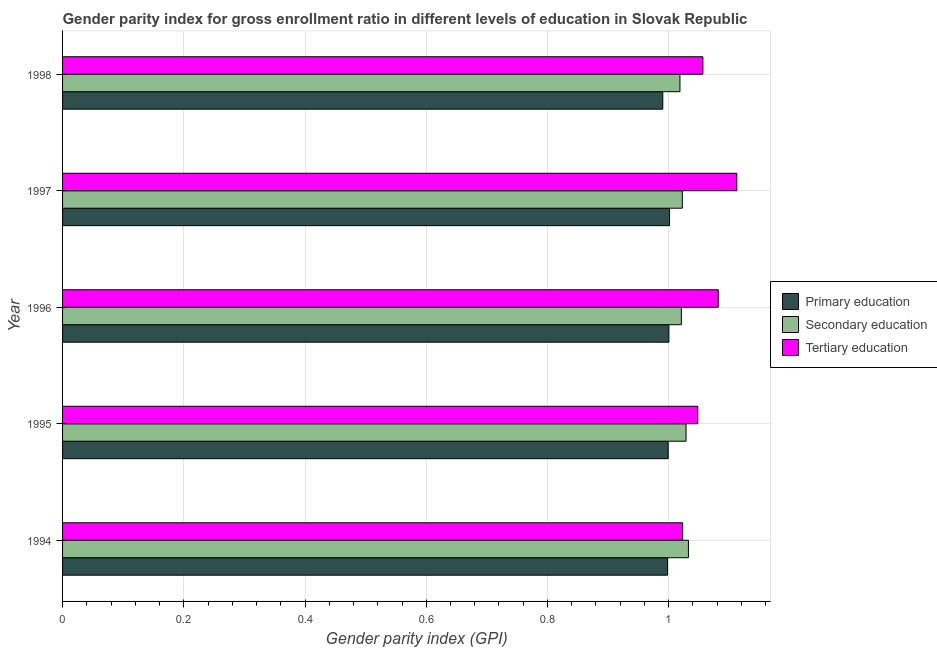How many groups of bars are there?
Offer a terse response. 5. Are the number of bars on each tick of the Y-axis equal?
Offer a terse response. Yes. How many bars are there on the 2nd tick from the top?
Provide a succinct answer. 3. How many bars are there on the 2nd tick from the bottom?
Give a very brief answer. 3. What is the label of the 3rd group of bars from the top?
Offer a terse response. 1996. In how many cases, is the number of bars for a given year not equal to the number of legend labels?
Your answer should be compact. 0. What is the gender parity index in primary education in 1997?
Give a very brief answer. 1. Across all years, what is the maximum gender parity index in tertiary education?
Provide a short and direct response. 1.11. Across all years, what is the minimum gender parity index in secondary education?
Offer a terse response. 1.02. What is the total gender parity index in tertiary education in the graph?
Give a very brief answer. 5.32. What is the difference between the gender parity index in secondary education in 1994 and that in 1998?
Offer a very short reply. 0.01. What is the difference between the gender parity index in primary education in 1998 and the gender parity index in tertiary education in 1997?
Provide a short and direct response. -0.12. What is the average gender parity index in tertiary education per year?
Your answer should be very brief. 1.06. In the year 1997, what is the difference between the gender parity index in secondary education and gender parity index in primary education?
Keep it short and to the point. 0.02. What is the ratio of the gender parity index in tertiary education in 1994 to that in 1998?
Your answer should be very brief. 0.97. Is the gender parity index in primary education in 1995 less than that in 1997?
Provide a short and direct response. Yes. What is the difference between the highest and the second highest gender parity index in tertiary education?
Your response must be concise. 0.03. What is the difference between the highest and the lowest gender parity index in secondary education?
Your answer should be compact. 0.01. In how many years, is the gender parity index in primary education greater than the average gender parity index in primary education taken over all years?
Provide a short and direct response. 4. Is the sum of the gender parity index in tertiary education in 1996 and 1997 greater than the maximum gender parity index in secondary education across all years?
Your answer should be very brief. Yes. What does the 2nd bar from the top in 1998 represents?
Provide a short and direct response. Secondary education. What does the 2nd bar from the bottom in 1996 represents?
Provide a succinct answer. Secondary education. Are all the bars in the graph horizontal?
Provide a short and direct response. Yes. How many years are there in the graph?
Give a very brief answer. 5. Are the values on the major ticks of X-axis written in scientific E-notation?
Provide a succinct answer. No. Does the graph contain any zero values?
Provide a succinct answer. No. What is the title of the graph?
Provide a short and direct response. Gender parity index for gross enrollment ratio in different levels of education in Slovak Republic. Does "Natural Gas" appear as one of the legend labels in the graph?
Provide a succinct answer. No. What is the label or title of the X-axis?
Your answer should be very brief. Gender parity index (GPI). What is the label or title of the Y-axis?
Provide a succinct answer. Year. What is the Gender parity index (GPI) in Primary education in 1994?
Provide a short and direct response. 1. What is the Gender parity index (GPI) in Secondary education in 1994?
Offer a very short reply. 1.03. What is the Gender parity index (GPI) in Tertiary education in 1994?
Ensure brevity in your answer.  1.02. What is the Gender parity index (GPI) of Primary education in 1995?
Your answer should be compact. 1. What is the Gender parity index (GPI) in Secondary education in 1995?
Offer a terse response. 1.03. What is the Gender parity index (GPI) of Tertiary education in 1995?
Your answer should be very brief. 1.05. What is the Gender parity index (GPI) in Primary education in 1996?
Your answer should be very brief. 1. What is the Gender parity index (GPI) in Secondary education in 1996?
Provide a short and direct response. 1.02. What is the Gender parity index (GPI) of Tertiary education in 1996?
Keep it short and to the point. 1.08. What is the Gender parity index (GPI) of Primary education in 1997?
Your response must be concise. 1. What is the Gender parity index (GPI) in Secondary education in 1997?
Your answer should be compact. 1.02. What is the Gender parity index (GPI) of Tertiary education in 1997?
Offer a very short reply. 1.11. What is the Gender parity index (GPI) in Primary education in 1998?
Make the answer very short. 0.99. What is the Gender parity index (GPI) in Secondary education in 1998?
Give a very brief answer. 1.02. What is the Gender parity index (GPI) in Tertiary education in 1998?
Keep it short and to the point. 1.06. Across all years, what is the maximum Gender parity index (GPI) in Primary education?
Ensure brevity in your answer.  1. Across all years, what is the maximum Gender parity index (GPI) of Secondary education?
Make the answer very short. 1.03. Across all years, what is the maximum Gender parity index (GPI) of Tertiary education?
Keep it short and to the point. 1.11. Across all years, what is the minimum Gender parity index (GPI) in Primary education?
Your answer should be very brief. 0.99. Across all years, what is the minimum Gender parity index (GPI) in Secondary education?
Your answer should be very brief. 1.02. Across all years, what is the minimum Gender parity index (GPI) of Tertiary education?
Your answer should be compact. 1.02. What is the total Gender parity index (GPI) in Primary education in the graph?
Provide a succinct answer. 4.99. What is the total Gender parity index (GPI) of Secondary education in the graph?
Your response must be concise. 5.12. What is the total Gender parity index (GPI) in Tertiary education in the graph?
Give a very brief answer. 5.32. What is the difference between the Gender parity index (GPI) in Primary education in 1994 and that in 1995?
Provide a short and direct response. -0. What is the difference between the Gender parity index (GPI) of Secondary education in 1994 and that in 1995?
Ensure brevity in your answer.  0. What is the difference between the Gender parity index (GPI) of Tertiary education in 1994 and that in 1995?
Give a very brief answer. -0.03. What is the difference between the Gender parity index (GPI) of Primary education in 1994 and that in 1996?
Your response must be concise. -0. What is the difference between the Gender parity index (GPI) in Secondary education in 1994 and that in 1996?
Keep it short and to the point. 0.01. What is the difference between the Gender parity index (GPI) of Tertiary education in 1994 and that in 1996?
Offer a terse response. -0.06. What is the difference between the Gender parity index (GPI) in Primary education in 1994 and that in 1997?
Keep it short and to the point. -0. What is the difference between the Gender parity index (GPI) in Secondary education in 1994 and that in 1997?
Your response must be concise. 0.01. What is the difference between the Gender parity index (GPI) in Tertiary education in 1994 and that in 1997?
Ensure brevity in your answer.  -0.09. What is the difference between the Gender parity index (GPI) of Primary education in 1994 and that in 1998?
Provide a short and direct response. 0.01. What is the difference between the Gender parity index (GPI) of Secondary education in 1994 and that in 1998?
Your answer should be very brief. 0.01. What is the difference between the Gender parity index (GPI) of Tertiary education in 1994 and that in 1998?
Make the answer very short. -0.03. What is the difference between the Gender parity index (GPI) of Primary education in 1995 and that in 1996?
Keep it short and to the point. -0. What is the difference between the Gender parity index (GPI) in Secondary education in 1995 and that in 1996?
Provide a succinct answer. 0.01. What is the difference between the Gender parity index (GPI) in Tertiary education in 1995 and that in 1996?
Offer a very short reply. -0.03. What is the difference between the Gender parity index (GPI) in Primary education in 1995 and that in 1997?
Your answer should be very brief. -0. What is the difference between the Gender parity index (GPI) of Secondary education in 1995 and that in 1997?
Offer a very short reply. 0.01. What is the difference between the Gender parity index (GPI) in Tertiary education in 1995 and that in 1997?
Ensure brevity in your answer.  -0.06. What is the difference between the Gender parity index (GPI) in Primary education in 1995 and that in 1998?
Your answer should be compact. 0.01. What is the difference between the Gender parity index (GPI) of Secondary education in 1995 and that in 1998?
Ensure brevity in your answer.  0.01. What is the difference between the Gender parity index (GPI) of Tertiary education in 1995 and that in 1998?
Provide a succinct answer. -0.01. What is the difference between the Gender parity index (GPI) of Primary education in 1996 and that in 1997?
Make the answer very short. -0. What is the difference between the Gender parity index (GPI) of Secondary education in 1996 and that in 1997?
Offer a terse response. -0. What is the difference between the Gender parity index (GPI) of Tertiary education in 1996 and that in 1997?
Offer a very short reply. -0.03. What is the difference between the Gender parity index (GPI) in Primary education in 1996 and that in 1998?
Keep it short and to the point. 0.01. What is the difference between the Gender parity index (GPI) in Secondary education in 1996 and that in 1998?
Make the answer very short. 0. What is the difference between the Gender parity index (GPI) of Tertiary education in 1996 and that in 1998?
Offer a terse response. 0.03. What is the difference between the Gender parity index (GPI) of Primary education in 1997 and that in 1998?
Keep it short and to the point. 0.01. What is the difference between the Gender parity index (GPI) in Secondary education in 1997 and that in 1998?
Provide a short and direct response. 0. What is the difference between the Gender parity index (GPI) in Tertiary education in 1997 and that in 1998?
Make the answer very short. 0.06. What is the difference between the Gender parity index (GPI) in Primary education in 1994 and the Gender parity index (GPI) in Secondary education in 1995?
Offer a very short reply. -0.03. What is the difference between the Gender parity index (GPI) in Primary education in 1994 and the Gender parity index (GPI) in Tertiary education in 1995?
Your answer should be very brief. -0.05. What is the difference between the Gender parity index (GPI) in Secondary education in 1994 and the Gender parity index (GPI) in Tertiary education in 1995?
Give a very brief answer. -0.02. What is the difference between the Gender parity index (GPI) in Primary education in 1994 and the Gender parity index (GPI) in Secondary education in 1996?
Provide a succinct answer. -0.02. What is the difference between the Gender parity index (GPI) of Primary education in 1994 and the Gender parity index (GPI) of Tertiary education in 1996?
Make the answer very short. -0.08. What is the difference between the Gender parity index (GPI) in Secondary education in 1994 and the Gender parity index (GPI) in Tertiary education in 1996?
Keep it short and to the point. -0.05. What is the difference between the Gender parity index (GPI) in Primary education in 1994 and the Gender parity index (GPI) in Secondary education in 1997?
Provide a short and direct response. -0.02. What is the difference between the Gender parity index (GPI) of Primary education in 1994 and the Gender parity index (GPI) of Tertiary education in 1997?
Provide a succinct answer. -0.11. What is the difference between the Gender parity index (GPI) in Secondary education in 1994 and the Gender parity index (GPI) in Tertiary education in 1997?
Make the answer very short. -0.08. What is the difference between the Gender parity index (GPI) of Primary education in 1994 and the Gender parity index (GPI) of Secondary education in 1998?
Your answer should be compact. -0.02. What is the difference between the Gender parity index (GPI) of Primary education in 1994 and the Gender parity index (GPI) of Tertiary education in 1998?
Your response must be concise. -0.06. What is the difference between the Gender parity index (GPI) of Secondary education in 1994 and the Gender parity index (GPI) of Tertiary education in 1998?
Offer a terse response. -0.02. What is the difference between the Gender parity index (GPI) in Primary education in 1995 and the Gender parity index (GPI) in Secondary education in 1996?
Offer a very short reply. -0.02. What is the difference between the Gender parity index (GPI) of Primary education in 1995 and the Gender parity index (GPI) of Tertiary education in 1996?
Your answer should be compact. -0.08. What is the difference between the Gender parity index (GPI) of Secondary education in 1995 and the Gender parity index (GPI) of Tertiary education in 1996?
Your response must be concise. -0.05. What is the difference between the Gender parity index (GPI) in Primary education in 1995 and the Gender parity index (GPI) in Secondary education in 1997?
Offer a terse response. -0.02. What is the difference between the Gender parity index (GPI) of Primary education in 1995 and the Gender parity index (GPI) of Tertiary education in 1997?
Offer a very short reply. -0.11. What is the difference between the Gender parity index (GPI) in Secondary education in 1995 and the Gender parity index (GPI) in Tertiary education in 1997?
Provide a succinct answer. -0.08. What is the difference between the Gender parity index (GPI) of Primary education in 1995 and the Gender parity index (GPI) of Secondary education in 1998?
Ensure brevity in your answer.  -0.02. What is the difference between the Gender parity index (GPI) of Primary education in 1995 and the Gender parity index (GPI) of Tertiary education in 1998?
Ensure brevity in your answer.  -0.06. What is the difference between the Gender parity index (GPI) in Secondary education in 1995 and the Gender parity index (GPI) in Tertiary education in 1998?
Offer a terse response. -0.03. What is the difference between the Gender parity index (GPI) of Primary education in 1996 and the Gender parity index (GPI) of Secondary education in 1997?
Provide a succinct answer. -0.02. What is the difference between the Gender parity index (GPI) of Primary education in 1996 and the Gender parity index (GPI) of Tertiary education in 1997?
Provide a succinct answer. -0.11. What is the difference between the Gender parity index (GPI) of Secondary education in 1996 and the Gender parity index (GPI) of Tertiary education in 1997?
Your response must be concise. -0.09. What is the difference between the Gender parity index (GPI) in Primary education in 1996 and the Gender parity index (GPI) in Secondary education in 1998?
Your response must be concise. -0.02. What is the difference between the Gender parity index (GPI) of Primary education in 1996 and the Gender parity index (GPI) of Tertiary education in 1998?
Your response must be concise. -0.06. What is the difference between the Gender parity index (GPI) of Secondary education in 1996 and the Gender parity index (GPI) of Tertiary education in 1998?
Ensure brevity in your answer.  -0.04. What is the difference between the Gender parity index (GPI) in Primary education in 1997 and the Gender parity index (GPI) in Secondary education in 1998?
Keep it short and to the point. -0.02. What is the difference between the Gender parity index (GPI) in Primary education in 1997 and the Gender parity index (GPI) in Tertiary education in 1998?
Provide a short and direct response. -0.06. What is the difference between the Gender parity index (GPI) in Secondary education in 1997 and the Gender parity index (GPI) in Tertiary education in 1998?
Make the answer very short. -0.03. What is the average Gender parity index (GPI) of Secondary education per year?
Your response must be concise. 1.02. What is the average Gender parity index (GPI) of Tertiary education per year?
Keep it short and to the point. 1.06. In the year 1994, what is the difference between the Gender parity index (GPI) in Primary education and Gender parity index (GPI) in Secondary education?
Give a very brief answer. -0.03. In the year 1994, what is the difference between the Gender parity index (GPI) in Primary education and Gender parity index (GPI) in Tertiary education?
Offer a terse response. -0.02. In the year 1994, what is the difference between the Gender parity index (GPI) in Secondary education and Gender parity index (GPI) in Tertiary education?
Make the answer very short. 0.01. In the year 1995, what is the difference between the Gender parity index (GPI) of Primary education and Gender parity index (GPI) of Secondary education?
Provide a succinct answer. -0.03. In the year 1995, what is the difference between the Gender parity index (GPI) of Primary education and Gender parity index (GPI) of Tertiary education?
Offer a terse response. -0.05. In the year 1995, what is the difference between the Gender parity index (GPI) of Secondary education and Gender parity index (GPI) of Tertiary education?
Your answer should be very brief. -0.02. In the year 1996, what is the difference between the Gender parity index (GPI) in Primary education and Gender parity index (GPI) in Secondary education?
Give a very brief answer. -0.02. In the year 1996, what is the difference between the Gender parity index (GPI) of Primary education and Gender parity index (GPI) of Tertiary education?
Provide a succinct answer. -0.08. In the year 1996, what is the difference between the Gender parity index (GPI) in Secondary education and Gender parity index (GPI) in Tertiary education?
Your answer should be compact. -0.06. In the year 1997, what is the difference between the Gender parity index (GPI) of Primary education and Gender parity index (GPI) of Secondary education?
Provide a short and direct response. -0.02. In the year 1997, what is the difference between the Gender parity index (GPI) of Primary education and Gender parity index (GPI) of Tertiary education?
Provide a short and direct response. -0.11. In the year 1997, what is the difference between the Gender parity index (GPI) in Secondary education and Gender parity index (GPI) in Tertiary education?
Make the answer very short. -0.09. In the year 1998, what is the difference between the Gender parity index (GPI) of Primary education and Gender parity index (GPI) of Secondary education?
Provide a short and direct response. -0.03. In the year 1998, what is the difference between the Gender parity index (GPI) of Primary education and Gender parity index (GPI) of Tertiary education?
Your response must be concise. -0.07. In the year 1998, what is the difference between the Gender parity index (GPI) in Secondary education and Gender parity index (GPI) in Tertiary education?
Keep it short and to the point. -0.04. What is the ratio of the Gender parity index (GPI) of Primary education in 1994 to that in 1995?
Provide a succinct answer. 1. What is the ratio of the Gender parity index (GPI) in Secondary education in 1994 to that in 1995?
Provide a short and direct response. 1. What is the ratio of the Gender parity index (GPI) of Tertiary education in 1994 to that in 1995?
Give a very brief answer. 0.98. What is the ratio of the Gender parity index (GPI) in Primary education in 1994 to that in 1996?
Offer a very short reply. 1. What is the ratio of the Gender parity index (GPI) of Secondary education in 1994 to that in 1996?
Keep it short and to the point. 1.01. What is the ratio of the Gender parity index (GPI) in Tertiary education in 1994 to that in 1996?
Offer a very short reply. 0.95. What is the ratio of the Gender parity index (GPI) in Primary education in 1994 to that in 1997?
Keep it short and to the point. 1. What is the ratio of the Gender parity index (GPI) of Secondary education in 1994 to that in 1997?
Your response must be concise. 1.01. What is the ratio of the Gender parity index (GPI) in Tertiary education in 1994 to that in 1997?
Provide a succinct answer. 0.92. What is the ratio of the Gender parity index (GPI) in Primary education in 1994 to that in 1998?
Your answer should be compact. 1.01. What is the ratio of the Gender parity index (GPI) in Secondary education in 1994 to that in 1998?
Keep it short and to the point. 1.01. What is the ratio of the Gender parity index (GPI) in Tertiary education in 1994 to that in 1998?
Your answer should be very brief. 0.97. What is the ratio of the Gender parity index (GPI) in Secondary education in 1995 to that in 1996?
Make the answer very short. 1.01. What is the ratio of the Gender parity index (GPI) of Tertiary education in 1995 to that in 1996?
Ensure brevity in your answer.  0.97. What is the ratio of the Gender parity index (GPI) of Secondary education in 1995 to that in 1997?
Provide a succinct answer. 1.01. What is the ratio of the Gender parity index (GPI) of Tertiary education in 1995 to that in 1997?
Provide a succinct answer. 0.94. What is the ratio of the Gender parity index (GPI) in Primary education in 1995 to that in 1998?
Give a very brief answer. 1.01. What is the ratio of the Gender parity index (GPI) in Secondary education in 1995 to that in 1998?
Provide a short and direct response. 1.01. What is the ratio of the Gender parity index (GPI) of Tertiary education in 1995 to that in 1998?
Offer a very short reply. 0.99. What is the ratio of the Gender parity index (GPI) of Tertiary education in 1996 to that in 1997?
Your answer should be very brief. 0.97. What is the ratio of the Gender parity index (GPI) of Primary education in 1996 to that in 1998?
Give a very brief answer. 1.01. What is the ratio of the Gender parity index (GPI) of Secondary education in 1996 to that in 1998?
Ensure brevity in your answer.  1. What is the ratio of the Gender parity index (GPI) in Tertiary education in 1996 to that in 1998?
Your answer should be very brief. 1.02. What is the ratio of the Gender parity index (GPI) in Primary education in 1997 to that in 1998?
Provide a succinct answer. 1.01. What is the ratio of the Gender parity index (GPI) in Tertiary education in 1997 to that in 1998?
Keep it short and to the point. 1.05. What is the difference between the highest and the second highest Gender parity index (GPI) of Primary education?
Provide a succinct answer. 0. What is the difference between the highest and the second highest Gender parity index (GPI) in Secondary education?
Offer a very short reply. 0. What is the difference between the highest and the second highest Gender parity index (GPI) in Tertiary education?
Provide a succinct answer. 0.03. What is the difference between the highest and the lowest Gender parity index (GPI) in Primary education?
Ensure brevity in your answer.  0.01. What is the difference between the highest and the lowest Gender parity index (GPI) in Secondary education?
Offer a very short reply. 0.01. What is the difference between the highest and the lowest Gender parity index (GPI) in Tertiary education?
Keep it short and to the point. 0.09. 